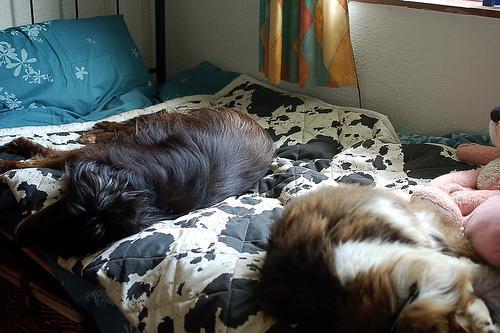How many animals are on the bed?
Give a very brief answer. 2. How many pillows are on the bed?
Give a very brief answer. 1. 